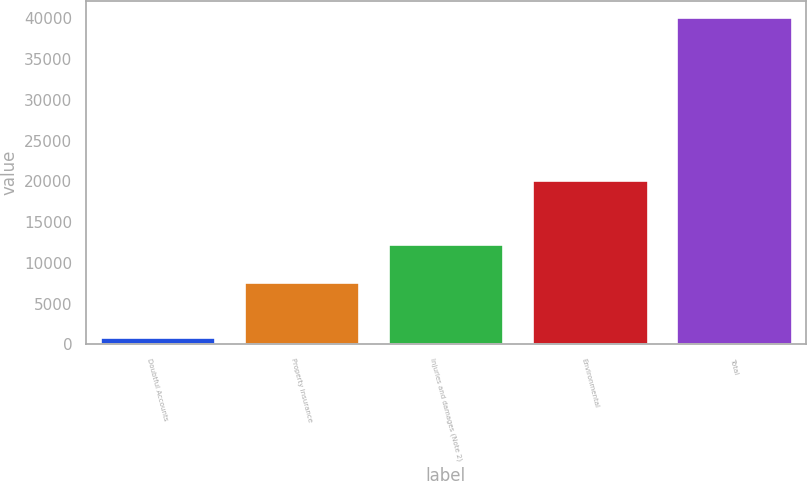Convert chart to OTSL. <chart><loc_0><loc_0><loc_500><loc_500><bar_chart><fcel>Doubtful Accounts<fcel>Property insurance<fcel>Injuries and damages (Note 2)<fcel>Environmental<fcel>Total<nl><fcel>889<fcel>7673<fcel>12288<fcel>20201<fcel>40162<nl></chart> 